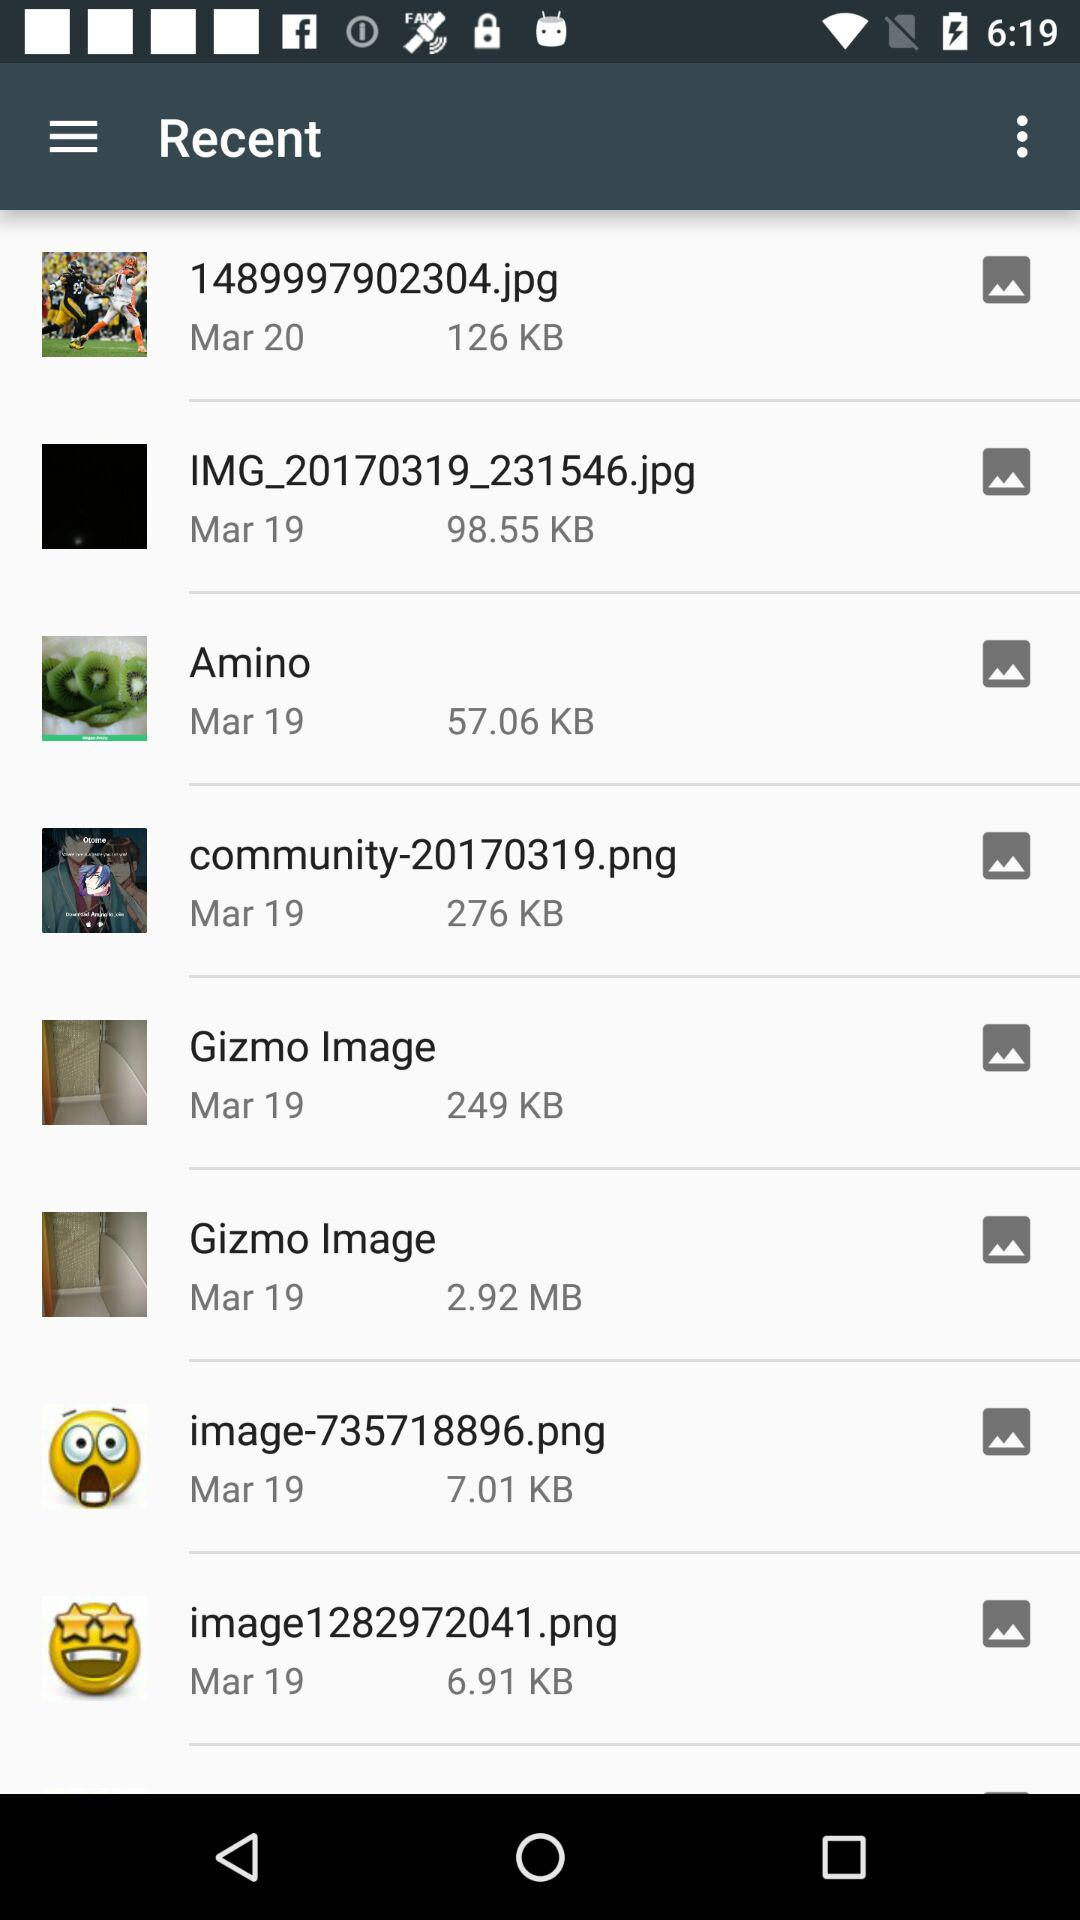What is the size of the "Amino" photo in KB? The size of the "Amino" photo is 57.06 KB. 